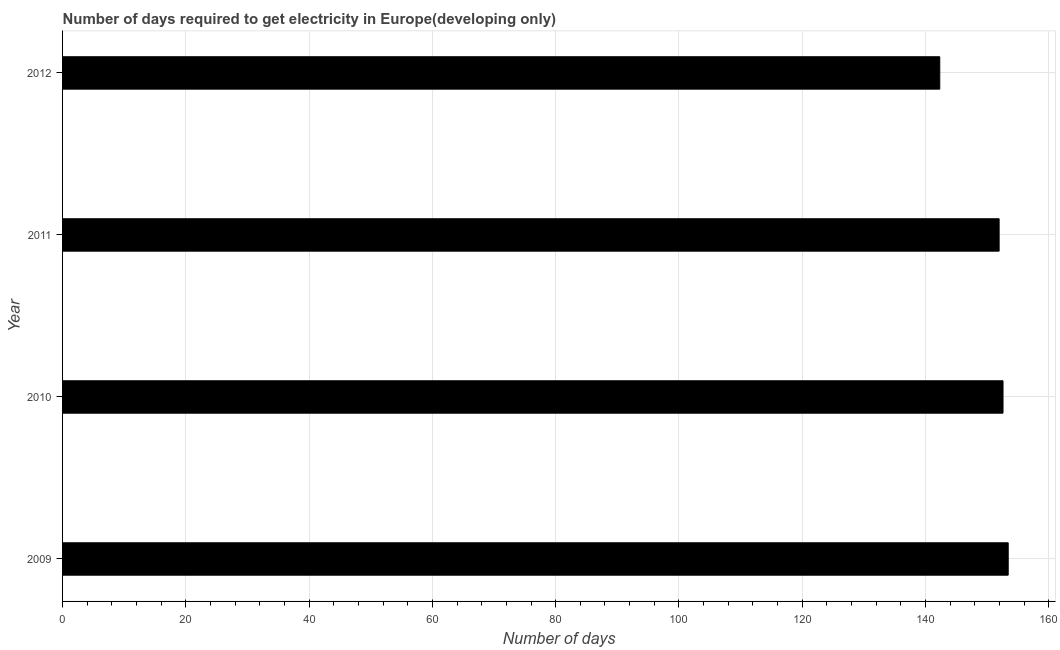Does the graph contain any zero values?
Your answer should be very brief. No. Does the graph contain grids?
Your answer should be compact. Yes. What is the title of the graph?
Provide a short and direct response. Number of days required to get electricity in Europe(developing only). What is the label or title of the X-axis?
Make the answer very short. Number of days. What is the time to get electricity in 2010?
Offer a terse response. 152.58. Across all years, what is the maximum time to get electricity?
Keep it short and to the point. 153.42. Across all years, what is the minimum time to get electricity?
Ensure brevity in your answer.  142.32. In which year was the time to get electricity maximum?
Ensure brevity in your answer.  2009. In which year was the time to get electricity minimum?
Make the answer very short. 2012. What is the sum of the time to get electricity?
Keep it short and to the point. 600.26. What is the difference between the time to get electricity in 2010 and 2012?
Your response must be concise. 10.26. What is the average time to get electricity per year?
Ensure brevity in your answer.  150.07. What is the median time to get electricity?
Make the answer very short. 152.26. Do a majority of the years between 2010 and 2012 (inclusive) have time to get electricity greater than 4 ?
Your answer should be very brief. Yes. What is the ratio of the time to get electricity in 2010 to that in 2011?
Make the answer very short. 1. Is the time to get electricity in 2010 less than that in 2012?
Provide a succinct answer. No. Is the difference between the time to get electricity in 2009 and 2010 greater than the difference between any two years?
Provide a succinct answer. No. What is the difference between the highest and the second highest time to get electricity?
Provide a succinct answer. 0.84. What is the difference between the highest and the lowest time to get electricity?
Your answer should be compact. 11.11. Are all the bars in the graph horizontal?
Offer a very short reply. Yes. How many years are there in the graph?
Provide a succinct answer. 4. What is the Number of days in 2009?
Your answer should be very brief. 153.42. What is the Number of days in 2010?
Offer a terse response. 152.58. What is the Number of days of 2011?
Your answer should be very brief. 151.95. What is the Number of days of 2012?
Offer a terse response. 142.32. What is the difference between the Number of days in 2009 and 2010?
Your answer should be very brief. 0.84. What is the difference between the Number of days in 2009 and 2011?
Make the answer very short. 1.47. What is the difference between the Number of days in 2009 and 2012?
Offer a terse response. 11.11. What is the difference between the Number of days in 2010 and 2011?
Keep it short and to the point. 0.63. What is the difference between the Number of days in 2010 and 2012?
Keep it short and to the point. 10.26. What is the difference between the Number of days in 2011 and 2012?
Give a very brief answer. 9.63. What is the ratio of the Number of days in 2009 to that in 2012?
Give a very brief answer. 1.08. What is the ratio of the Number of days in 2010 to that in 2011?
Ensure brevity in your answer.  1. What is the ratio of the Number of days in 2010 to that in 2012?
Ensure brevity in your answer.  1.07. What is the ratio of the Number of days in 2011 to that in 2012?
Offer a very short reply. 1.07. 